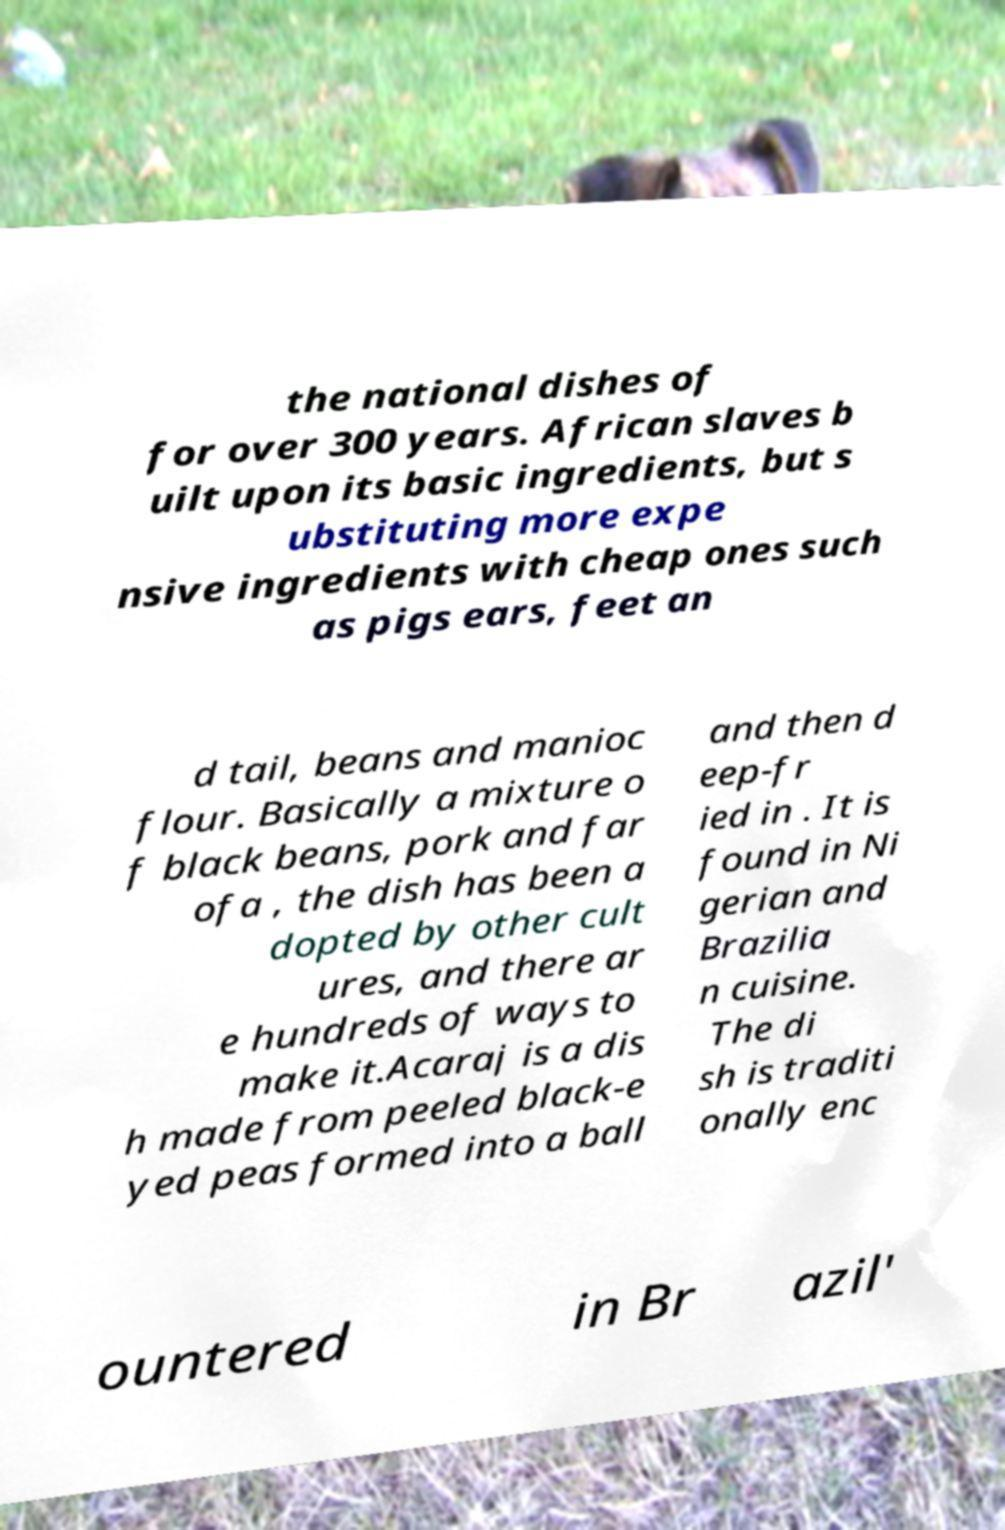There's text embedded in this image that I need extracted. Can you transcribe it verbatim? the national dishes of for over 300 years. African slaves b uilt upon its basic ingredients, but s ubstituting more expe nsive ingredients with cheap ones such as pigs ears, feet an d tail, beans and manioc flour. Basically a mixture o f black beans, pork and far ofa , the dish has been a dopted by other cult ures, and there ar e hundreds of ways to make it.Acaraj is a dis h made from peeled black-e yed peas formed into a ball and then d eep-fr ied in . It is found in Ni gerian and Brazilia n cuisine. The di sh is traditi onally enc ountered in Br azil' 